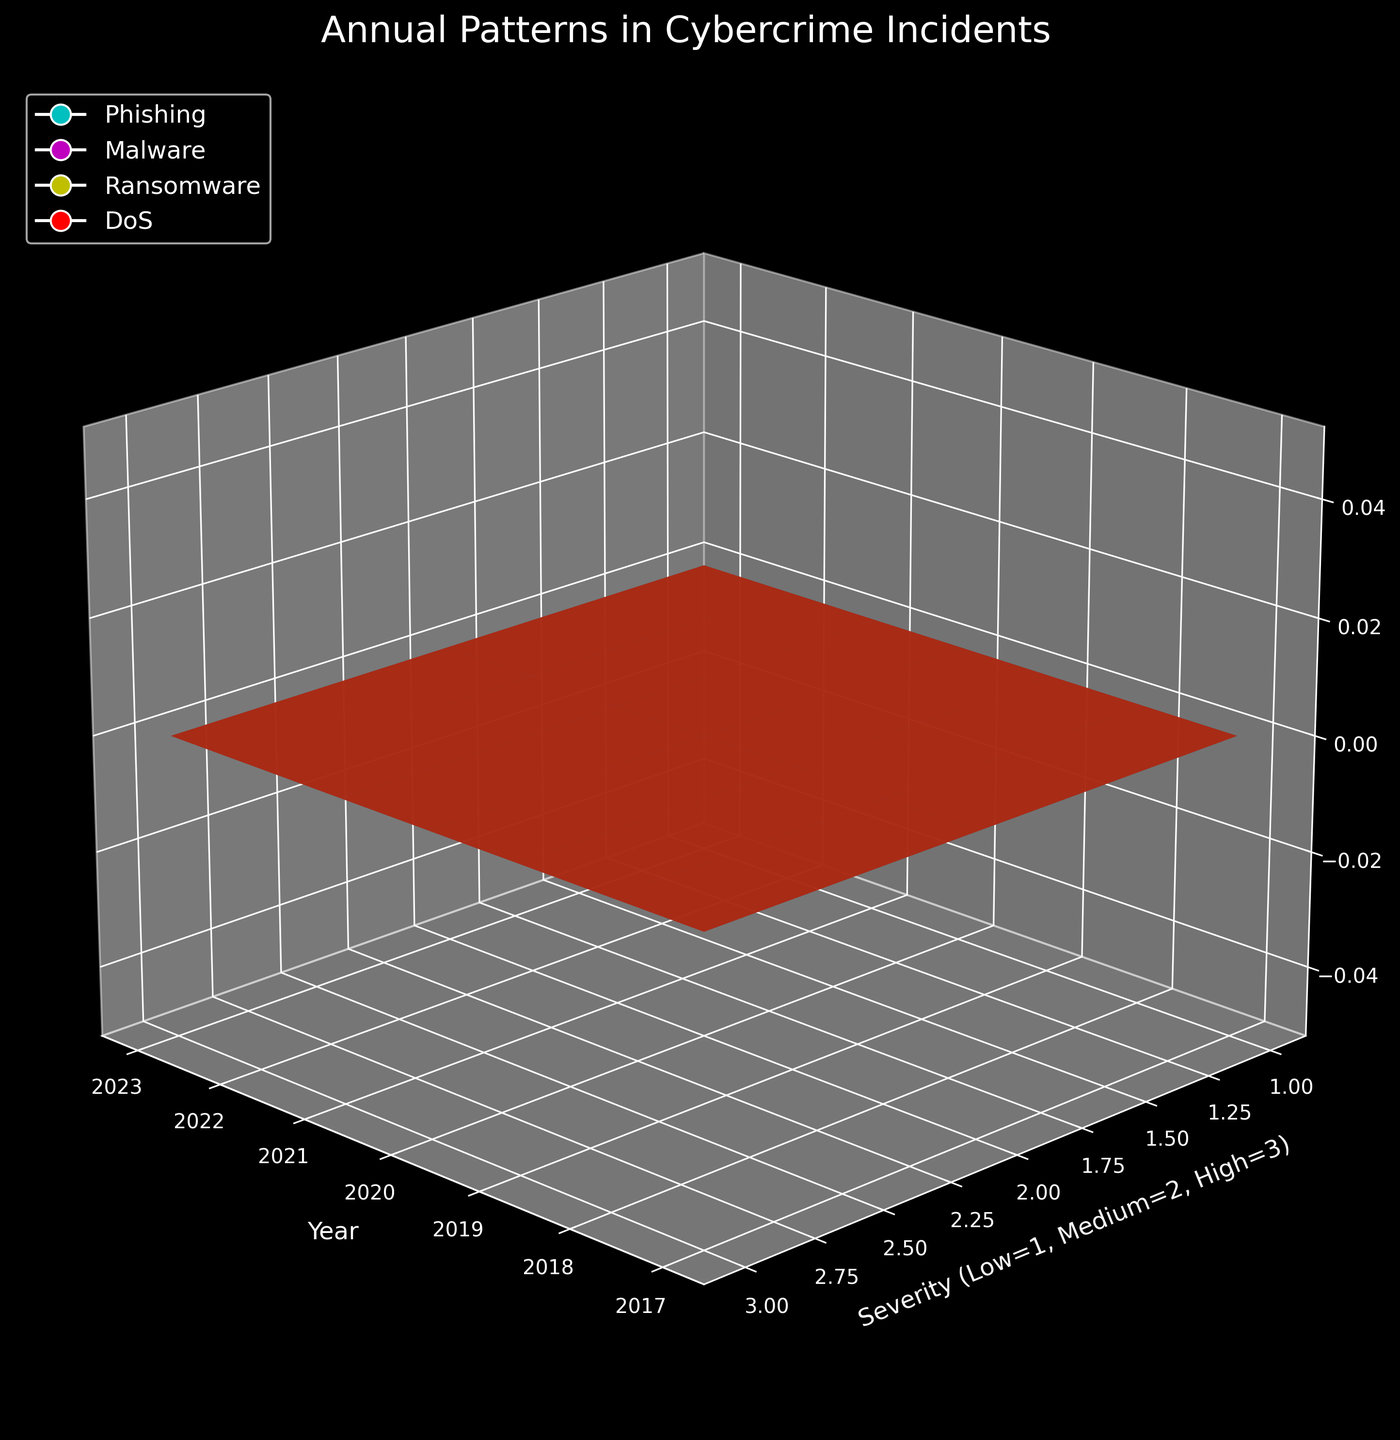Which method has the highest number of incidents across all severities in 2019? Look for the peaks in the plot for 2019 and identify which method has the tallest combined height across Low, Medium, and High severities.
Answer: DoS Which year saw the highest incidents of High severity Ransomware attacks? Identify the tallest peak in the plot for Ransomware under High severity for all years.
Answer: 2023 How did the number of Medium severity Phishing incidents change from 2017 to 2023? Compare the height of the Medium severity Phishing line in 2017 and 2023 and see whether it increased, decreased, or stayed the same.
Answer: Increased What is the average number of High severity incidents across all methods in 2021? Sum the High severity incidents for all methods in 2021 and divide by the number of methods (4) to get the average.
Answer: 77.5 In which year did Malware incidents first surpass 300 across all severities combined? Calculate the sum of Low, Medium, and High severity incidents for Malware each year and check when it first exceeds 300.
Answer: 2020 Which method shows the least variability in incident counts across all years and severities? Examine the surface plots for each method and observe which has the least variation in peak heights.
Answer: Phishing Compare the number of Low severity incidents for DoS and Malware in 2022. Which is greater? Look at the heights of the Low severity incidents for DoS and Malware in 2022 and compare them.
Answer: DoS What is the trend of High severity DoS incidents from 2017 to 2023? Observe the height changes for High severity DoS incidents across the years and identify the trend (increasing, decreasing, or stable).
Answer: Increasing How does the severity distribution for Phishing incidents in 2022 compare to 2023? Compare the relative heights of Low, Medium, and High severity incidents for Phishing in 2022 and 2023.
Answer: All increased 